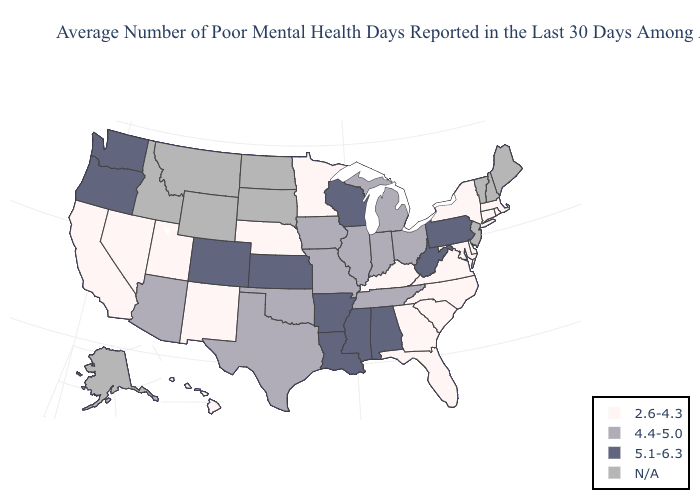Does Kansas have the lowest value in the USA?
Write a very short answer. No. Name the states that have a value in the range N/A?
Give a very brief answer. Alaska, Idaho, Maine, Montana, New Hampshire, New Jersey, North Dakota, South Dakota, Vermont, Wyoming. What is the highest value in states that border Louisiana?
Answer briefly. 5.1-6.3. What is the lowest value in the South?
Concise answer only. 2.6-4.3. Name the states that have a value in the range 5.1-6.3?
Give a very brief answer. Alabama, Arkansas, Colorado, Kansas, Louisiana, Mississippi, Oregon, Pennsylvania, Washington, West Virginia, Wisconsin. What is the lowest value in states that border Maryland?
Write a very short answer. 2.6-4.3. Name the states that have a value in the range N/A?
Quick response, please. Alaska, Idaho, Maine, Montana, New Hampshire, New Jersey, North Dakota, South Dakota, Vermont, Wyoming. What is the highest value in the West ?
Quick response, please. 5.1-6.3. Does Tennessee have the highest value in the South?
Short answer required. No. How many symbols are there in the legend?
Keep it brief. 4. Does Oregon have the highest value in the USA?
Short answer required. Yes. What is the value of Ohio?
Short answer required. 4.4-5.0. Name the states that have a value in the range 5.1-6.3?
Write a very short answer. Alabama, Arkansas, Colorado, Kansas, Louisiana, Mississippi, Oregon, Pennsylvania, Washington, West Virginia, Wisconsin. Name the states that have a value in the range 4.4-5.0?
Give a very brief answer. Arizona, Illinois, Indiana, Iowa, Michigan, Missouri, Ohio, Oklahoma, Tennessee, Texas. 